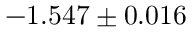<formula> <loc_0><loc_0><loc_500><loc_500>- 1 . 5 4 7 \pm 0 . 0 1 6</formula> 